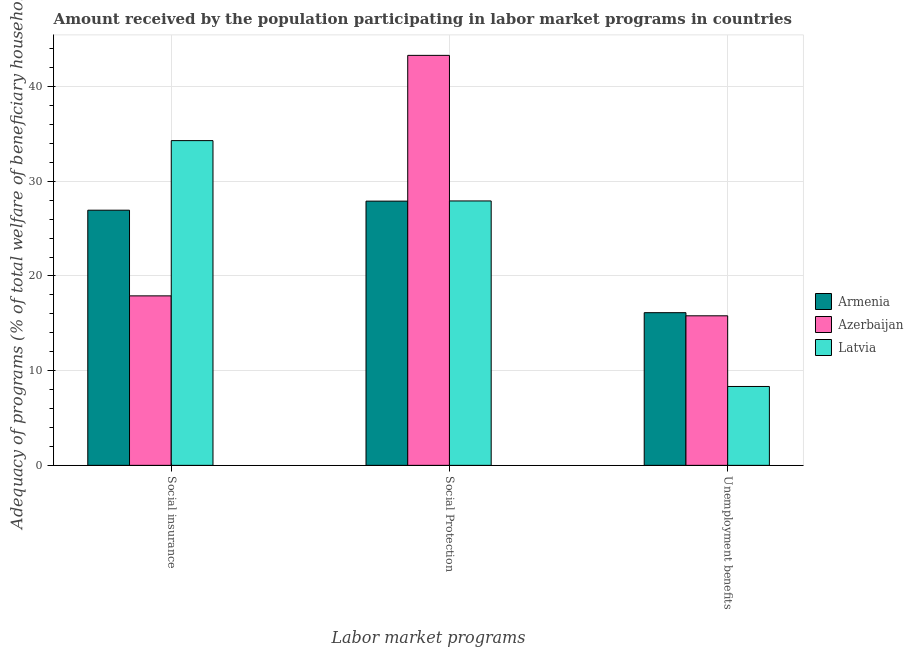How many different coloured bars are there?
Give a very brief answer. 3. How many groups of bars are there?
Offer a very short reply. 3. Are the number of bars per tick equal to the number of legend labels?
Your response must be concise. Yes. Are the number of bars on each tick of the X-axis equal?
Provide a succinct answer. Yes. How many bars are there on the 2nd tick from the right?
Give a very brief answer. 3. What is the label of the 2nd group of bars from the left?
Offer a very short reply. Social Protection. What is the amount received by the population participating in social insurance programs in Armenia?
Make the answer very short. 26.95. Across all countries, what is the maximum amount received by the population participating in unemployment benefits programs?
Your response must be concise. 16.12. Across all countries, what is the minimum amount received by the population participating in social insurance programs?
Provide a short and direct response. 17.9. In which country was the amount received by the population participating in social insurance programs maximum?
Make the answer very short. Latvia. In which country was the amount received by the population participating in social insurance programs minimum?
Your response must be concise. Azerbaijan. What is the total amount received by the population participating in social protection programs in the graph?
Keep it short and to the point. 99.13. What is the difference between the amount received by the population participating in social protection programs in Azerbaijan and that in Armenia?
Give a very brief answer. 15.39. What is the difference between the amount received by the population participating in social insurance programs in Azerbaijan and the amount received by the population participating in social protection programs in Latvia?
Your response must be concise. -10.03. What is the average amount received by the population participating in social protection programs per country?
Offer a very short reply. 33.04. What is the difference between the amount received by the population participating in unemployment benefits programs and amount received by the population participating in social insurance programs in Latvia?
Ensure brevity in your answer.  -25.97. In how many countries, is the amount received by the population participating in unemployment benefits programs greater than 18 %?
Offer a very short reply. 0. What is the ratio of the amount received by the population participating in social protection programs in Latvia to that in Armenia?
Keep it short and to the point. 1. Is the amount received by the population participating in social protection programs in Armenia less than that in Azerbaijan?
Ensure brevity in your answer.  Yes. What is the difference between the highest and the second highest amount received by the population participating in social protection programs?
Your answer should be compact. 15.37. What is the difference between the highest and the lowest amount received by the population participating in unemployment benefits programs?
Your answer should be very brief. 7.79. Is the sum of the amount received by the population participating in unemployment benefits programs in Latvia and Armenia greater than the maximum amount received by the population participating in social insurance programs across all countries?
Ensure brevity in your answer.  No. What does the 1st bar from the left in Social Protection represents?
Make the answer very short. Armenia. What does the 2nd bar from the right in Unemployment benefits represents?
Offer a very short reply. Azerbaijan. Are all the bars in the graph horizontal?
Ensure brevity in your answer.  No. How many countries are there in the graph?
Ensure brevity in your answer.  3. What is the difference between two consecutive major ticks on the Y-axis?
Offer a very short reply. 10. Does the graph contain any zero values?
Your answer should be compact. No. Where does the legend appear in the graph?
Provide a succinct answer. Center right. How are the legend labels stacked?
Provide a short and direct response. Vertical. What is the title of the graph?
Give a very brief answer. Amount received by the population participating in labor market programs in countries. What is the label or title of the X-axis?
Offer a terse response. Labor market programs. What is the label or title of the Y-axis?
Provide a short and direct response. Adequacy of programs (% of total welfare of beneficiary households). What is the Adequacy of programs (% of total welfare of beneficiary households) of Armenia in Social insurance?
Offer a very short reply. 26.95. What is the Adequacy of programs (% of total welfare of beneficiary households) in Azerbaijan in Social insurance?
Provide a succinct answer. 17.9. What is the Adequacy of programs (% of total welfare of beneficiary households) of Latvia in Social insurance?
Provide a succinct answer. 34.3. What is the Adequacy of programs (% of total welfare of beneficiary households) of Armenia in Social Protection?
Your answer should be very brief. 27.91. What is the Adequacy of programs (% of total welfare of beneficiary households) of Azerbaijan in Social Protection?
Make the answer very short. 43.3. What is the Adequacy of programs (% of total welfare of beneficiary households) of Latvia in Social Protection?
Keep it short and to the point. 27.93. What is the Adequacy of programs (% of total welfare of beneficiary households) of Armenia in Unemployment benefits?
Your answer should be very brief. 16.12. What is the Adequacy of programs (% of total welfare of beneficiary households) of Azerbaijan in Unemployment benefits?
Your answer should be compact. 15.8. What is the Adequacy of programs (% of total welfare of beneficiary households) in Latvia in Unemployment benefits?
Offer a terse response. 8.33. Across all Labor market programs, what is the maximum Adequacy of programs (% of total welfare of beneficiary households) of Armenia?
Offer a terse response. 27.91. Across all Labor market programs, what is the maximum Adequacy of programs (% of total welfare of beneficiary households) in Azerbaijan?
Make the answer very short. 43.3. Across all Labor market programs, what is the maximum Adequacy of programs (% of total welfare of beneficiary households) of Latvia?
Ensure brevity in your answer.  34.3. Across all Labor market programs, what is the minimum Adequacy of programs (% of total welfare of beneficiary households) in Armenia?
Keep it short and to the point. 16.12. Across all Labor market programs, what is the minimum Adequacy of programs (% of total welfare of beneficiary households) in Azerbaijan?
Keep it short and to the point. 15.8. Across all Labor market programs, what is the minimum Adequacy of programs (% of total welfare of beneficiary households) of Latvia?
Ensure brevity in your answer.  8.33. What is the total Adequacy of programs (% of total welfare of beneficiary households) in Armenia in the graph?
Provide a succinct answer. 70.98. What is the total Adequacy of programs (% of total welfare of beneficiary households) in Azerbaijan in the graph?
Your response must be concise. 76.99. What is the total Adequacy of programs (% of total welfare of beneficiary households) of Latvia in the graph?
Your response must be concise. 70.55. What is the difference between the Adequacy of programs (% of total welfare of beneficiary households) in Armenia in Social insurance and that in Social Protection?
Ensure brevity in your answer.  -0.96. What is the difference between the Adequacy of programs (% of total welfare of beneficiary households) of Azerbaijan in Social insurance and that in Social Protection?
Make the answer very short. -25.4. What is the difference between the Adequacy of programs (% of total welfare of beneficiary households) in Latvia in Social insurance and that in Social Protection?
Offer a very short reply. 6.37. What is the difference between the Adequacy of programs (% of total welfare of beneficiary households) in Armenia in Social insurance and that in Unemployment benefits?
Make the answer very short. 10.82. What is the difference between the Adequacy of programs (% of total welfare of beneficiary households) in Azerbaijan in Social insurance and that in Unemployment benefits?
Offer a very short reply. 2.1. What is the difference between the Adequacy of programs (% of total welfare of beneficiary households) in Latvia in Social insurance and that in Unemployment benefits?
Your answer should be compact. 25.97. What is the difference between the Adequacy of programs (% of total welfare of beneficiary households) in Armenia in Social Protection and that in Unemployment benefits?
Your answer should be compact. 11.78. What is the difference between the Adequacy of programs (% of total welfare of beneficiary households) of Azerbaijan in Social Protection and that in Unemployment benefits?
Make the answer very short. 27.5. What is the difference between the Adequacy of programs (% of total welfare of beneficiary households) in Latvia in Social Protection and that in Unemployment benefits?
Provide a short and direct response. 19.59. What is the difference between the Adequacy of programs (% of total welfare of beneficiary households) of Armenia in Social insurance and the Adequacy of programs (% of total welfare of beneficiary households) of Azerbaijan in Social Protection?
Your answer should be compact. -16.35. What is the difference between the Adequacy of programs (% of total welfare of beneficiary households) in Armenia in Social insurance and the Adequacy of programs (% of total welfare of beneficiary households) in Latvia in Social Protection?
Give a very brief answer. -0.98. What is the difference between the Adequacy of programs (% of total welfare of beneficiary households) of Azerbaijan in Social insurance and the Adequacy of programs (% of total welfare of beneficiary households) of Latvia in Social Protection?
Provide a succinct answer. -10.03. What is the difference between the Adequacy of programs (% of total welfare of beneficiary households) in Armenia in Social insurance and the Adequacy of programs (% of total welfare of beneficiary households) in Azerbaijan in Unemployment benefits?
Your answer should be very brief. 11.15. What is the difference between the Adequacy of programs (% of total welfare of beneficiary households) in Armenia in Social insurance and the Adequacy of programs (% of total welfare of beneficiary households) in Latvia in Unemployment benefits?
Your response must be concise. 18.62. What is the difference between the Adequacy of programs (% of total welfare of beneficiary households) in Azerbaijan in Social insurance and the Adequacy of programs (% of total welfare of beneficiary households) in Latvia in Unemployment benefits?
Provide a succinct answer. 9.57. What is the difference between the Adequacy of programs (% of total welfare of beneficiary households) in Armenia in Social Protection and the Adequacy of programs (% of total welfare of beneficiary households) in Azerbaijan in Unemployment benefits?
Offer a very short reply. 12.11. What is the difference between the Adequacy of programs (% of total welfare of beneficiary households) in Armenia in Social Protection and the Adequacy of programs (% of total welfare of beneficiary households) in Latvia in Unemployment benefits?
Keep it short and to the point. 19.58. What is the difference between the Adequacy of programs (% of total welfare of beneficiary households) in Azerbaijan in Social Protection and the Adequacy of programs (% of total welfare of beneficiary households) in Latvia in Unemployment benefits?
Your answer should be very brief. 34.97. What is the average Adequacy of programs (% of total welfare of beneficiary households) of Armenia per Labor market programs?
Your answer should be compact. 23.66. What is the average Adequacy of programs (% of total welfare of beneficiary households) of Azerbaijan per Labor market programs?
Provide a short and direct response. 25.66. What is the average Adequacy of programs (% of total welfare of beneficiary households) of Latvia per Labor market programs?
Offer a terse response. 23.52. What is the difference between the Adequacy of programs (% of total welfare of beneficiary households) in Armenia and Adequacy of programs (% of total welfare of beneficiary households) in Azerbaijan in Social insurance?
Make the answer very short. 9.05. What is the difference between the Adequacy of programs (% of total welfare of beneficiary households) of Armenia and Adequacy of programs (% of total welfare of beneficiary households) of Latvia in Social insurance?
Offer a very short reply. -7.35. What is the difference between the Adequacy of programs (% of total welfare of beneficiary households) in Azerbaijan and Adequacy of programs (% of total welfare of beneficiary households) in Latvia in Social insurance?
Your response must be concise. -16.4. What is the difference between the Adequacy of programs (% of total welfare of beneficiary households) of Armenia and Adequacy of programs (% of total welfare of beneficiary households) of Azerbaijan in Social Protection?
Provide a succinct answer. -15.39. What is the difference between the Adequacy of programs (% of total welfare of beneficiary households) in Armenia and Adequacy of programs (% of total welfare of beneficiary households) in Latvia in Social Protection?
Provide a short and direct response. -0.02. What is the difference between the Adequacy of programs (% of total welfare of beneficiary households) of Azerbaijan and Adequacy of programs (% of total welfare of beneficiary households) of Latvia in Social Protection?
Your answer should be compact. 15.37. What is the difference between the Adequacy of programs (% of total welfare of beneficiary households) of Armenia and Adequacy of programs (% of total welfare of beneficiary households) of Azerbaijan in Unemployment benefits?
Ensure brevity in your answer.  0.33. What is the difference between the Adequacy of programs (% of total welfare of beneficiary households) in Armenia and Adequacy of programs (% of total welfare of beneficiary households) in Latvia in Unemployment benefits?
Make the answer very short. 7.79. What is the difference between the Adequacy of programs (% of total welfare of beneficiary households) of Azerbaijan and Adequacy of programs (% of total welfare of beneficiary households) of Latvia in Unemployment benefits?
Your answer should be very brief. 7.46. What is the ratio of the Adequacy of programs (% of total welfare of beneficiary households) of Armenia in Social insurance to that in Social Protection?
Offer a very short reply. 0.97. What is the ratio of the Adequacy of programs (% of total welfare of beneficiary households) of Azerbaijan in Social insurance to that in Social Protection?
Give a very brief answer. 0.41. What is the ratio of the Adequacy of programs (% of total welfare of beneficiary households) in Latvia in Social insurance to that in Social Protection?
Offer a terse response. 1.23. What is the ratio of the Adequacy of programs (% of total welfare of beneficiary households) in Armenia in Social insurance to that in Unemployment benefits?
Offer a terse response. 1.67. What is the ratio of the Adequacy of programs (% of total welfare of beneficiary households) in Azerbaijan in Social insurance to that in Unemployment benefits?
Offer a very short reply. 1.13. What is the ratio of the Adequacy of programs (% of total welfare of beneficiary households) in Latvia in Social insurance to that in Unemployment benefits?
Keep it short and to the point. 4.12. What is the ratio of the Adequacy of programs (% of total welfare of beneficiary households) of Armenia in Social Protection to that in Unemployment benefits?
Give a very brief answer. 1.73. What is the ratio of the Adequacy of programs (% of total welfare of beneficiary households) of Azerbaijan in Social Protection to that in Unemployment benefits?
Your answer should be compact. 2.74. What is the ratio of the Adequacy of programs (% of total welfare of beneficiary households) of Latvia in Social Protection to that in Unemployment benefits?
Keep it short and to the point. 3.35. What is the difference between the highest and the second highest Adequacy of programs (% of total welfare of beneficiary households) in Armenia?
Provide a short and direct response. 0.96. What is the difference between the highest and the second highest Adequacy of programs (% of total welfare of beneficiary households) in Azerbaijan?
Give a very brief answer. 25.4. What is the difference between the highest and the second highest Adequacy of programs (% of total welfare of beneficiary households) in Latvia?
Give a very brief answer. 6.37. What is the difference between the highest and the lowest Adequacy of programs (% of total welfare of beneficiary households) of Armenia?
Provide a succinct answer. 11.78. What is the difference between the highest and the lowest Adequacy of programs (% of total welfare of beneficiary households) in Azerbaijan?
Your answer should be very brief. 27.5. What is the difference between the highest and the lowest Adequacy of programs (% of total welfare of beneficiary households) of Latvia?
Give a very brief answer. 25.97. 